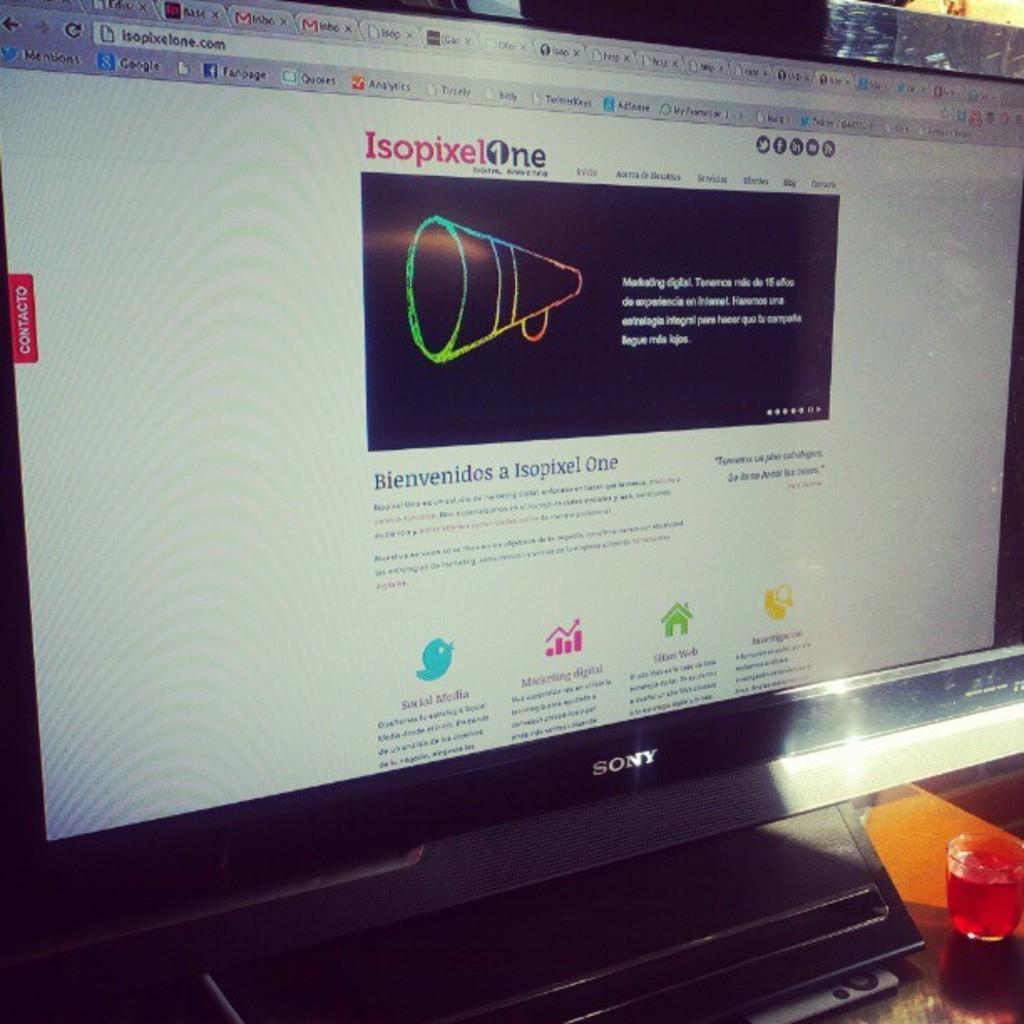What kind of pixel is mentioned at the top of the page?
Make the answer very short. Isopixel. What is the name of the article?
Offer a terse response. Bienvenidos a isopixel one. 